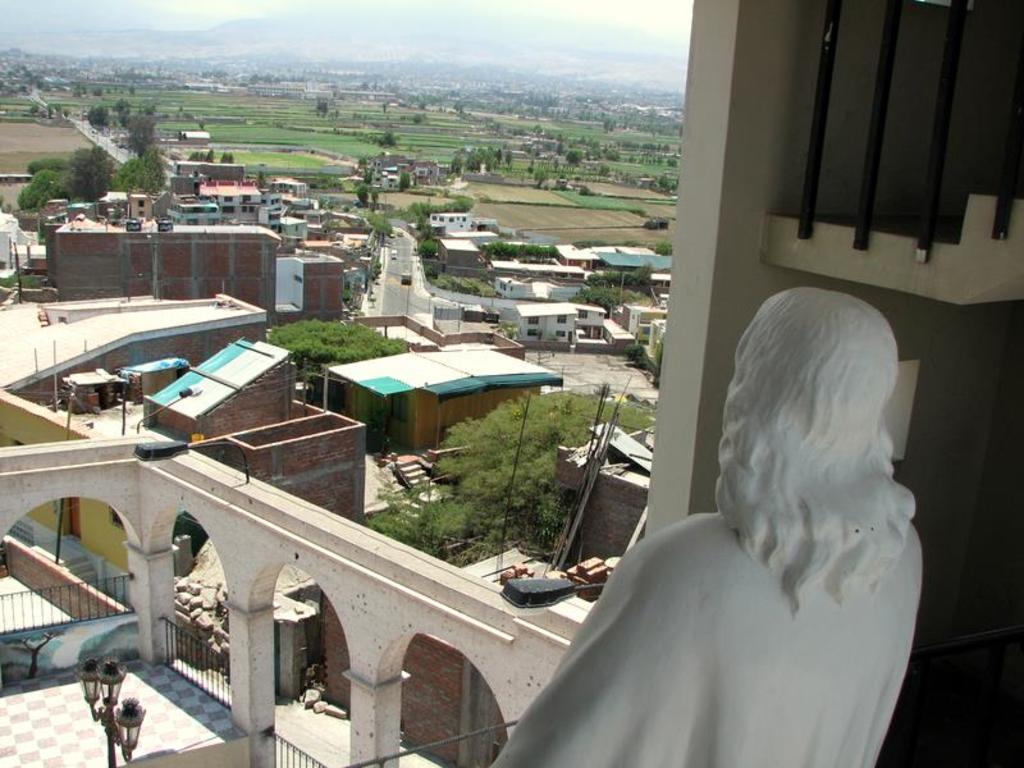Describe this image in one or two sentences. In the image we can see there are many buildings and trees. This is a fence, light pole, sculpture white in color, bricks and a sky. 